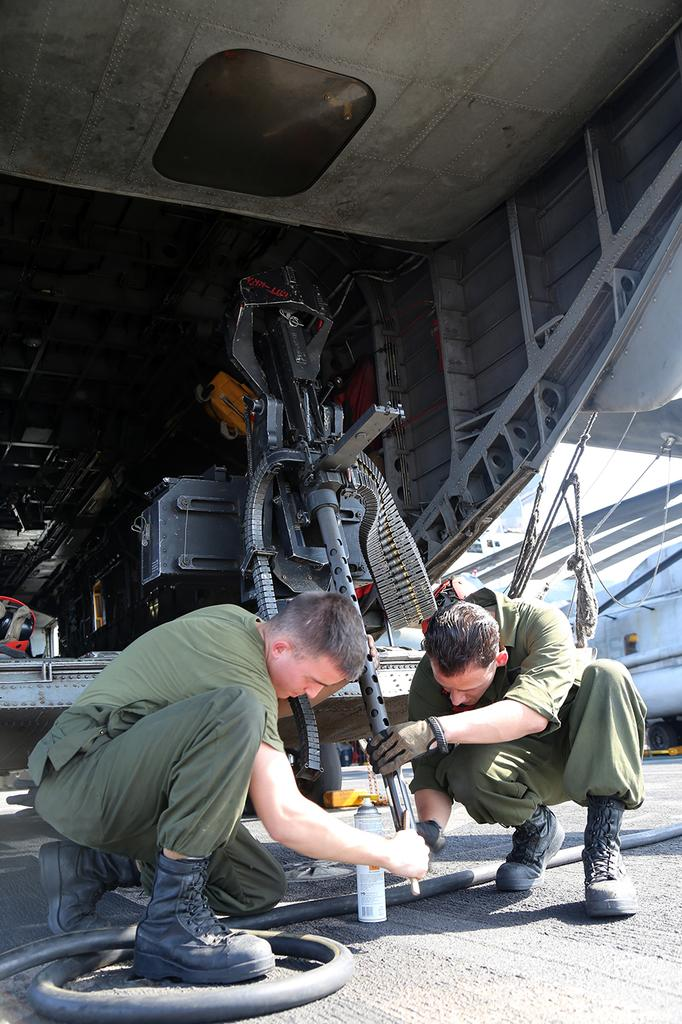How many people are in the image? There are two men in the image. What are the men doing in the image? The men are sitting on the road and holding a machine. Where is the machine located in the image? The machine is on a table. What is visible above the men in the image? There is a ceiling visible in the image. What type of oatmeal is being served on the furniture in the image? There is no oatmeal or furniture present in the image. What kind of cloud can be seen through the window in the image? There is no window or cloud visible in the image. 